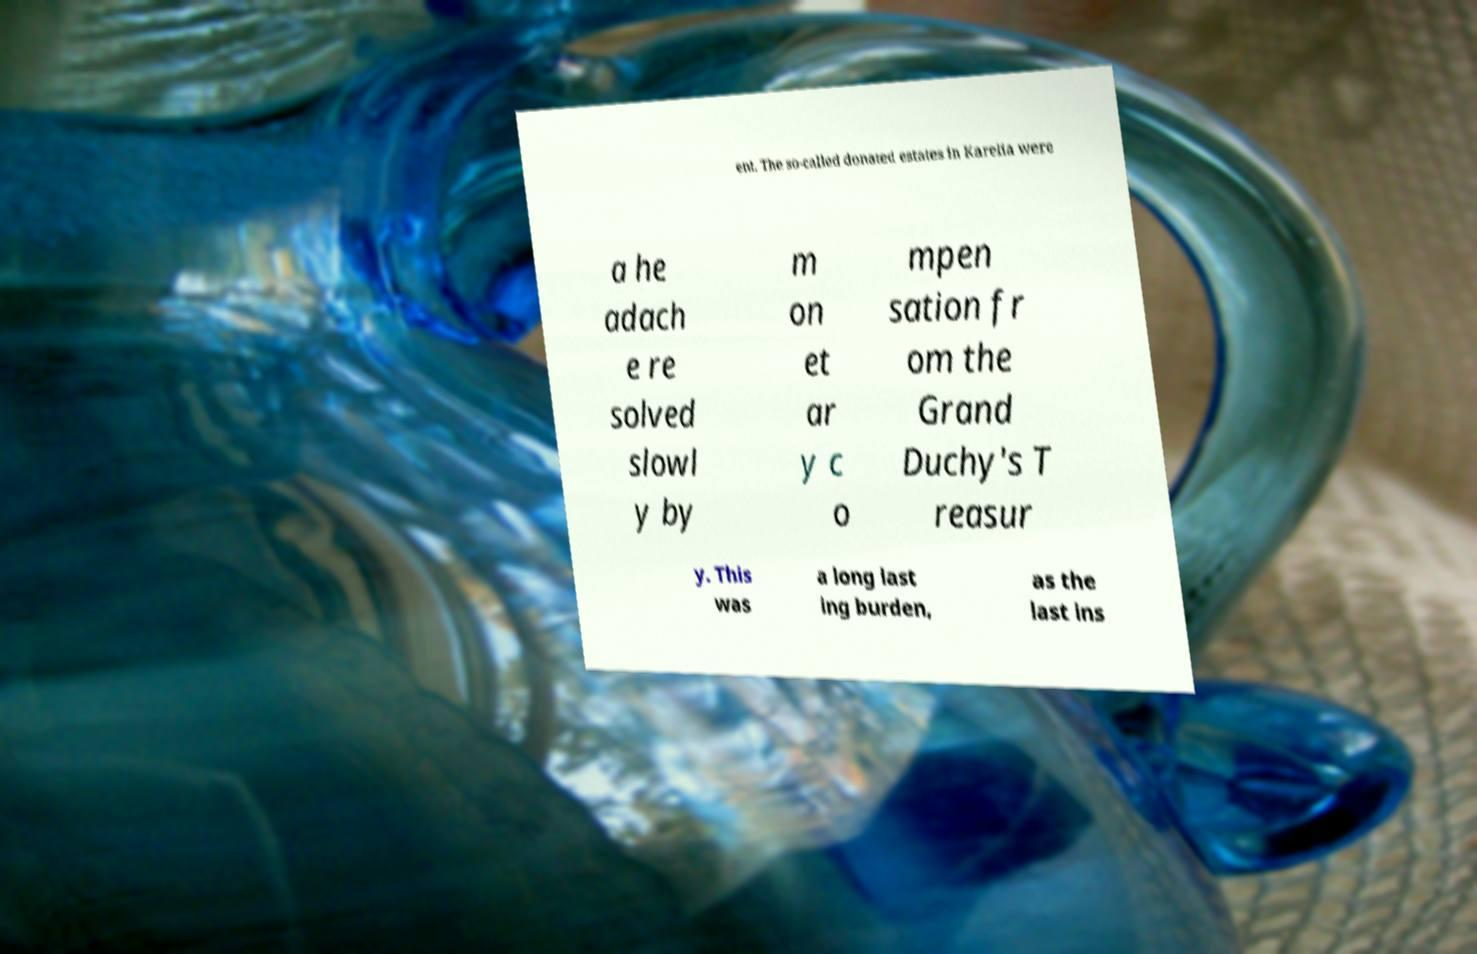For documentation purposes, I need the text within this image transcribed. Could you provide that? ent. The so-called donated estates in Karelia were a he adach e re solved slowl y by m on et ar y c o mpen sation fr om the Grand Duchy's T reasur y. This was a long last ing burden, as the last ins 